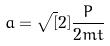Convert formula to latex. <formula><loc_0><loc_0><loc_500><loc_500>a = \sqrt { [ } 2 ] { \frac { P } { 2 m t } }</formula> 